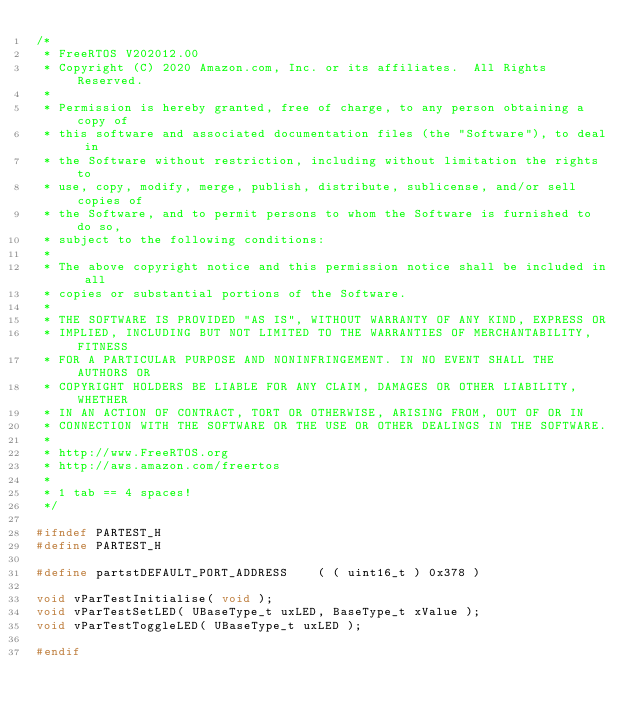Convert code to text. <code><loc_0><loc_0><loc_500><loc_500><_C_>/*
 * FreeRTOS V202012.00
 * Copyright (C) 2020 Amazon.com, Inc. or its affiliates.  All Rights Reserved.
 *
 * Permission is hereby granted, free of charge, to any person obtaining a copy of
 * this software and associated documentation files (the "Software"), to deal in
 * the Software without restriction, including without limitation the rights to
 * use, copy, modify, merge, publish, distribute, sublicense, and/or sell copies of
 * the Software, and to permit persons to whom the Software is furnished to do so,
 * subject to the following conditions:
 *
 * The above copyright notice and this permission notice shall be included in all
 * copies or substantial portions of the Software.
 *
 * THE SOFTWARE IS PROVIDED "AS IS", WITHOUT WARRANTY OF ANY KIND, EXPRESS OR
 * IMPLIED, INCLUDING BUT NOT LIMITED TO THE WARRANTIES OF MERCHANTABILITY, FITNESS
 * FOR A PARTICULAR PURPOSE AND NONINFRINGEMENT. IN NO EVENT SHALL THE AUTHORS OR
 * COPYRIGHT HOLDERS BE LIABLE FOR ANY CLAIM, DAMAGES OR OTHER LIABILITY, WHETHER
 * IN AN ACTION OF CONTRACT, TORT OR OTHERWISE, ARISING FROM, OUT OF OR IN
 * CONNECTION WITH THE SOFTWARE OR THE USE OR OTHER DEALINGS IN THE SOFTWARE.
 *
 * http://www.FreeRTOS.org
 * http://aws.amazon.com/freertos
 *
 * 1 tab == 4 spaces!
 */

#ifndef PARTEST_H
#define PARTEST_H

#define partstDEFAULT_PORT_ADDRESS		( ( uint16_t ) 0x378 )

void vParTestInitialise( void );
void vParTestSetLED( UBaseType_t uxLED, BaseType_t xValue );
void vParTestToggleLED( UBaseType_t uxLED );

#endif

</code> 